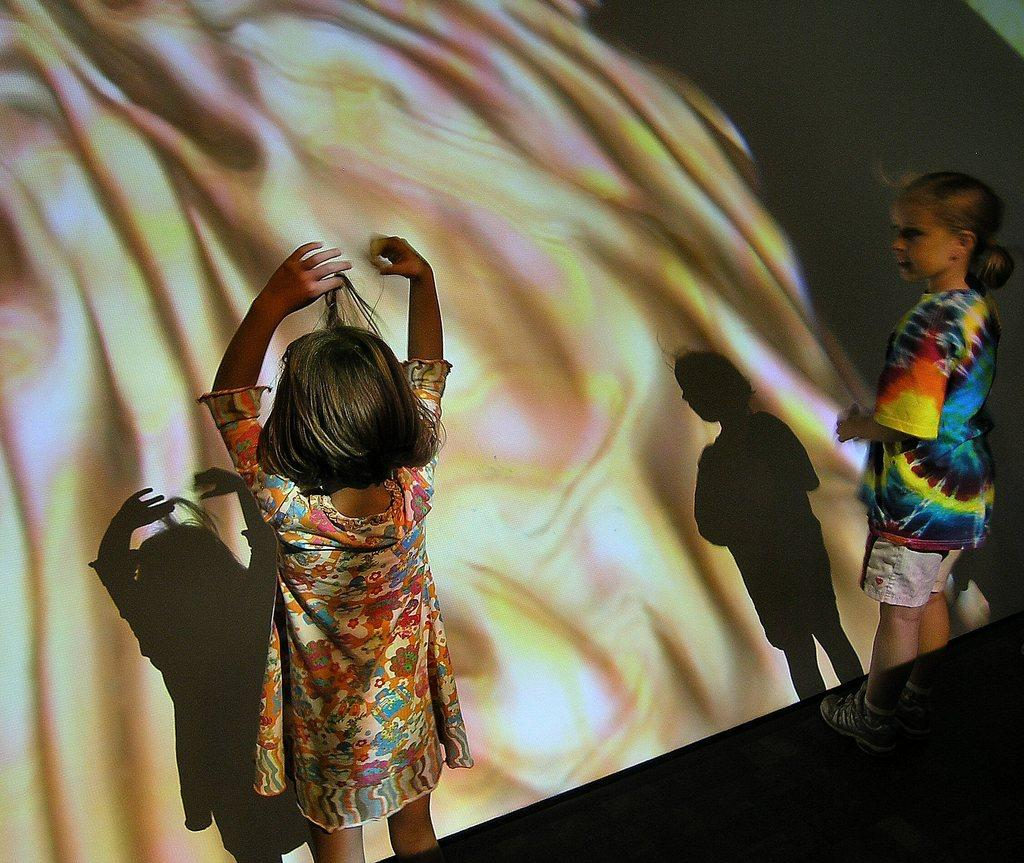How many people are present in the image? There are two people standing in the image. What is in front of the people? There is a screen in front of the people. What type of railway is visible in the image? There is no railway present in the image; it only features two people standing in front of a screen. What hobbies do the people have, as seen in the image? The image does not provide any information about the people's hobbies; it only shows them standing in front of a screen. 